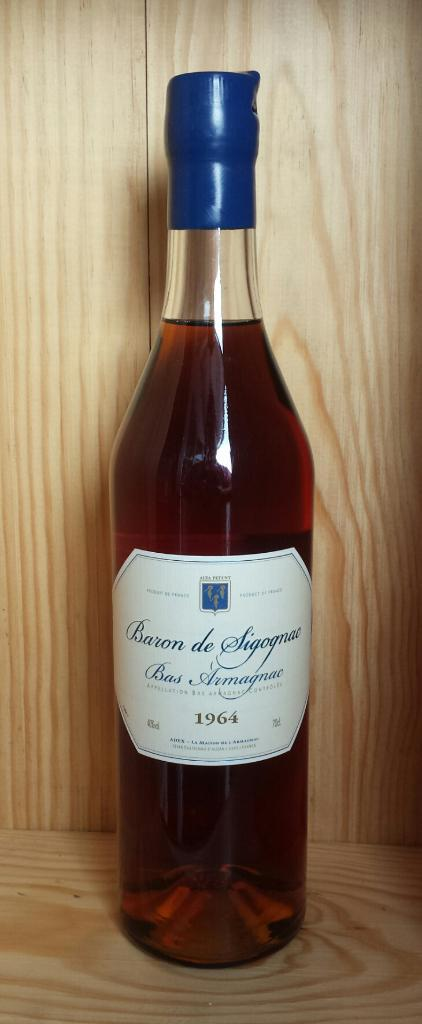<image>
Summarize the visual content of the image. An unopened bottle of Baron de Sigognac Bas Armagnac wine from 1964. 